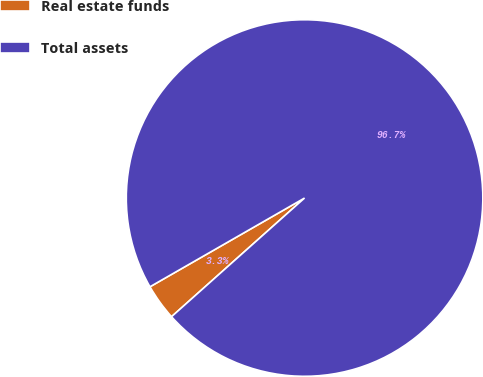<chart> <loc_0><loc_0><loc_500><loc_500><pie_chart><fcel>Real estate funds<fcel>Total assets<nl><fcel>3.3%<fcel>96.7%<nl></chart> 